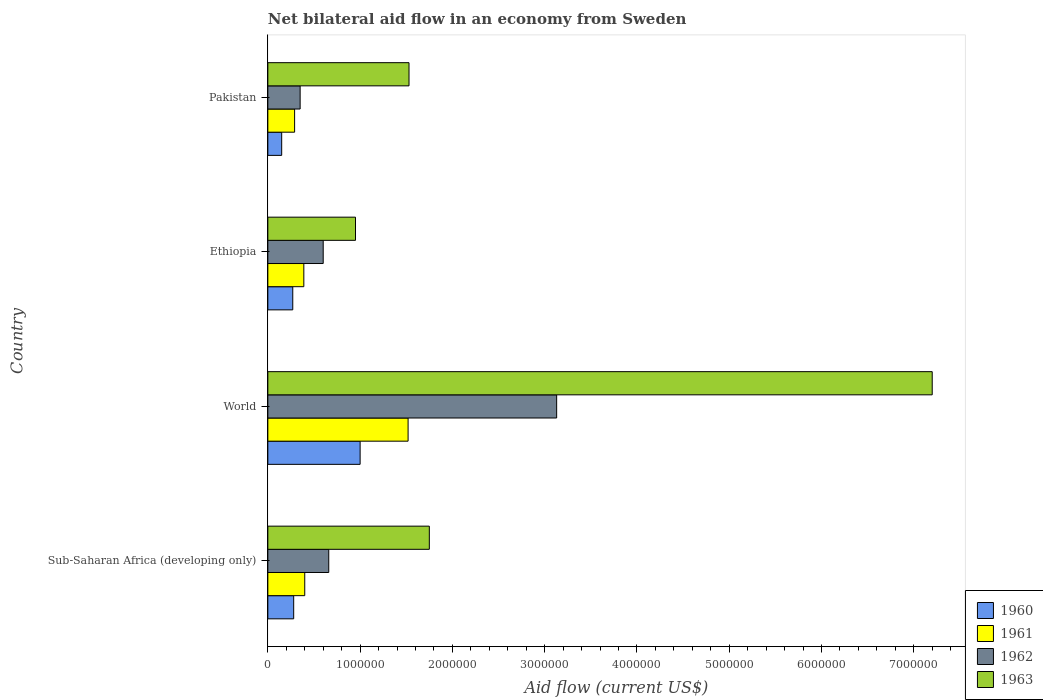How many different coloured bars are there?
Keep it short and to the point. 4. How many groups of bars are there?
Your response must be concise. 4. Are the number of bars per tick equal to the number of legend labels?
Offer a very short reply. Yes. Are the number of bars on each tick of the Y-axis equal?
Provide a succinct answer. Yes. How many bars are there on the 1st tick from the bottom?
Offer a terse response. 4. What is the label of the 4th group of bars from the top?
Give a very brief answer. Sub-Saharan Africa (developing only). In how many cases, is the number of bars for a given country not equal to the number of legend labels?
Your answer should be very brief. 0. What is the net bilateral aid flow in 1962 in Ethiopia?
Your answer should be very brief. 6.00e+05. Across all countries, what is the maximum net bilateral aid flow in 1962?
Your answer should be compact. 3.13e+06. Across all countries, what is the minimum net bilateral aid flow in 1963?
Offer a terse response. 9.50e+05. What is the total net bilateral aid flow in 1961 in the graph?
Provide a short and direct response. 2.60e+06. What is the difference between the net bilateral aid flow in 1963 in Pakistan and that in World?
Your response must be concise. -5.67e+06. What is the difference between the net bilateral aid flow in 1962 in Sub-Saharan Africa (developing only) and the net bilateral aid flow in 1963 in Pakistan?
Provide a short and direct response. -8.70e+05. What is the average net bilateral aid flow in 1960 per country?
Make the answer very short. 4.25e+05. What is the difference between the net bilateral aid flow in 1961 and net bilateral aid flow in 1963 in Ethiopia?
Your response must be concise. -5.60e+05. In how many countries, is the net bilateral aid flow in 1961 greater than 1800000 US$?
Make the answer very short. 0. What is the ratio of the net bilateral aid flow in 1961 in Sub-Saharan Africa (developing only) to that in World?
Ensure brevity in your answer.  0.26. Is the net bilateral aid flow in 1962 in Pakistan less than that in Sub-Saharan Africa (developing only)?
Your response must be concise. Yes. What is the difference between the highest and the second highest net bilateral aid flow in 1962?
Give a very brief answer. 2.47e+06. What is the difference between the highest and the lowest net bilateral aid flow in 1960?
Offer a terse response. 8.50e+05. In how many countries, is the net bilateral aid flow in 1960 greater than the average net bilateral aid flow in 1960 taken over all countries?
Give a very brief answer. 1. What does the 1st bar from the top in Ethiopia represents?
Offer a terse response. 1963. How many bars are there?
Ensure brevity in your answer.  16. Are all the bars in the graph horizontal?
Offer a very short reply. Yes. How many countries are there in the graph?
Give a very brief answer. 4. Are the values on the major ticks of X-axis written in scientific E-notation?
Ensure brevity in your answer.  No. Does the graph contain grids?
Ensure brevity in your answer.  No. Where does the legend appear in the graph?
Your answer should be compact. Bottom right. What is the title of the graph?
Offer a terse response. Net bilateral aid flow in an economy from Sweden. Does "2008" appear as one of the legend labels in the graph?
Keep it short and to the point. No. What is the label or title of the X-axis?
Offer a very short reply. Aid flow (current US$). What is the label or title of the Y-axis?
Your answer should be compact. Country. What is the Aid flow (current US$) in 1960 in Sub-Saharan Africa (developing only)?
Provide a short and direct response. 2.80e+05. What is the Aid flow (current US$) in 1962 in Sub-Saharan Africa (developing only)?
Provide a succinct answer. 6.60e+05. What is the Aid flow (current US$) in 1963 in Sub-Saharan Africa (developing only)?
Offer a very short reply. 1.75e+06. What is the Aid flow (current US$) of 1960 in World?
Give a very brief answer. 1.00e+06. What is the Aid flow (current US$) of 1961 in World?
Provide a succinct answer. 1.52e+06. What is the Aid flow (current US$) of 1962 in World?
Provide a short and direct response. 3.13e+06. What is the Aid flow (current US$) of 1963 in World?
Your answer should be very brief. 7.20e+06. What is the Aid flow (current US$) of 1960 in Ethiopia?
Offer a very short reply. 2.70e+05. What is the Aid flow (current US$) in 1961 in Ethiopia?
Keep it short and to the point. 3.90e+05. What is the Aid flow (current US$) in 1962 in Ethiopia?
Your response must be concise. 6.00e+05. What is the Aid flow (current US$) of 1963 in Ethiopia?
Provide a succinct answer. 9.50e+05. What is the Aid flow (current US$) in 1960 in Pakistan?
Make the answer very short. 1.50e+05. What is the Aid flow (current US$) in 1961 in Pakistan?
Your answer should be compact. 2.90e+05. What is the Aid flow (current US$) of 1963 in Pakistan?
Your answer should be compact. 1.53e+06. Across all countries, what is the maximum Aid flow (current US$) in 1960?
Your response must be concise. 1.00e+06. Across all countries, what is the maximum Aid flow (current US$) of 1961?
Your answer should be compact. 1.52e+06. Across all countries, what is the maximum Aid flow (current US$) in 1962?
Offer a terse response. 3.13e+06. Across all countries, what is the maximum Aid flow (current US$) of 1963?
Your answer should be very brief. 7.20e+06. Across all countries, what is the minimum Aid flow (current US$) of 1961?
Your answer should be compact. 2.90e+05. Across all countries, what is the minimum Aid flow (current US$) of 1963?
Keep it short and to the point. 9.50e+05. What is the total Aid flow (current US$) of 1960 in the graph?
Make the answer very short. 1.70e+06. What is the total Aid flow (current US$) of 1961 in the graph?
Offer a terse response. 2.60e+06. What is the total Aid flow (current US$) of 1962 in the graph?
Provide a short and direct response. 4.74e+06. What is the total Aid flow (current US$) of 1963 in the graph?
Give a very brief answer. 1.14e+07. What is the difference between the Aid flow (current US$) of 1960 in Sub-Saharan Africa (developing only) and that in World?
Your answer should be compact. -7.20e+05. What is the difference between the Aid flow (current US$) in 1961 in Sub-Saharan Africa (developing only) and that in World?
Your response must be concise. -1.12e+06. What is the difference between the Aid flow (current US$) in 1962 in Sub-Saharan Africa (developing only) and that in World?
Provide a succinct answer. -2.47e+06. What is the difference between the Aid flow (current US$) in 1963 in Sub-Saharan Africa (developing only) and that in World?
Ensure brevity in your answer.  -5.45e+06. What is the difference between the Aid flow (current US$) in 1960 in Sub-Saharan Africa (developing only) and that in Ethiopia?
Your answer should be compact. 10000. What is the difference between the Aid flow (current US$) of 1961 in Sub-Saharan Africa (developing only) and that in Ethiopia?
Give a very brief answer. 10000. What is the difference between the Aid flow (current US$) of 1962 in Sub-Saharan Africa (developing only) and that in Ethiopia?
Your response must be concise. 6.00e+04. What is the difference between the Aid flow (current US$) in 1963 in Sub-Saharan Africa (developing only) and that in Ethiopia?
Provide a succinct answer. 8.00e+05. What is the difference between the Aid flow (current US$) of 1962 in Sub-Saharan Africa (developing only) and that in Pakistan?
Give a very brief answer. 3.10e+05. What is the difference between the Aid flow (current US$) of 1960 in World and that in Ethiopia?
Make the answer very short. 7.30e+05. What is the difference between the Aid flow (current US$) in 1961 in World and that in Ethiopia?
Your answer should be compact. 1.13e+06. What is the difference between the Aid flow (current US$) in 1962 in World and that in Ethiopia?
Offer a very short reply. 2.53e+06. What is the difference between the Aid flow (current US$) in 1963 in World and that in Ethiopia?
Keep it short and to the point. 6.25e+06. What is the difference between the Aid flow (current US$) in 1960 in World and that in Pakistan?
Your response must be concise. 8.50e+05. What is the difference between the Aid flow (current US$) in 1961 in World and that in Pakistan?
Make the answer very short. 1.23e+06. What is the difference between the Aid flow (current US$) in 1962 in World and that in Pakistan?
Keep it short and to the point. 2.78e+06. What is the difference between the Aid flow (current US$) in 1963 in World and that in Pakistan?
Your answer should be compact. 5.67e+06. What is the difference between the Aid flow (current US$) in 1960 in Ethiopia and that in Pakistan?
Provide a succinct answer. 1.20e+05. What is the difference between the Aid flow (current US$) of 1961 in Ethiopia and that in Pakistan?
Provide a short and direct response. 1.00e+05. What is the difference between the Aid flow (current US$) of 1963 in Ethiopia and that in Pakistan?
Offer a terse response. -5.80e+05. What is the difference between the Aid flow (current US$) of 1960 in Sub-Saharan Africa (developing only) and the Aid flow (current US$) of 1961 in World?
Provide a short and direct response. -1.24e+06. What is the difference between the Aid flow (current US$) in 1960 in Sub-Saharan Africa (developing only) and the Aid flow (current US$) in 1962 in World?
Provide a succinct answer. -2.85e+06. What is the difference between the Aid flow (current US$) of 1960 in Sub-Saharan Africa (developing only) and the Aid flow (current US$) of 1963 in World?
Offer a very short reply. -6.92e+06. What is the difference between the Aid flow (current US$) of 1961 in Sub-Saharan Africa (developing only) and the Aid flow (current US$) of 1962 in World?
Keep it short and to the point. -2.73e+06. What is the difference between the Aid flow (current US$) of 1961 in Sub-Saharan Africa (developing only) and the Aid flow (current US$) of 1963 in World?
Offer a very short reply. -6.80e+06. What is the difference between the Aid flow (current US$) of 1962 in Sub-Saharan Africa (developing only) and the Aid flow (current US$) of 1963 in World?
Make the answer very short. -6.54e+06. What is the difference between the Aid flow (current US$) in 1960 in Sub-Saharan Africa (developing only) and the Aid flow (current US$) in 1961 in Ethiopia?
Your answer should be very brief. -1.10e+05. What is the difference between the Aid flow (current US$) in 1960 in Sub-Saharan Africa (developing only) and the Aid flow (current US$) in 1962 in Ethiopia?
Provide a succinct answer. -3.20e+05. What is the difference between the Aid flow (current US$) in 1960 in Sub-Saharan Africa (developing only) and the Aid flow (current US$) in 1963 in Ethiopia?
Make the answer very short. -6.70e+05. What is the difference between the Aid flow (current US$) of 1961 in Sub-Saharan Africa (developing only) and the Aid flow (current US$) of 1962 in Ethiopia?
Make the answer very short. -2.00e+05. What is the difference between the Aid flow (current US$) in 1961 in Sub-Saharan Africa (developing only) and the Aid flow (current US$) in 1963 in Ethiopia?
Give a very brief answer. -5.50e+05. What is the difference between the Aid flow (current US$) in 1960 in Sub-Saharan Africa (developing only) and the Aid flow (current US$) in 1963 in Pakistan?
Provide a short and direct response. -1.25e+06. What is the difference between the Aid flow (current US$) of 1961 in Sub-Saharan Africa (developing only) and the Aid flow (current US$) of 1963 in Pakistan?
Your answer should be very brief. -1.13e+06. What is the difference between the Aid flow (current US$) in 1962 in Sub-Saharan Africa (developing only) and the Aid flow (current US$) in 1963 in Pakistan?
Offer a very short reply. -8.70e+05. What is the difference between the Aid flow (current US$) of 1960 in World and the Aid flow (current US$) of 1962 in Ethiopia?
Provide a short and direct response. 4.00e+05. What is the difference between the Aid flow (current US$) in 1960 in World and the Aid flow (current US$) in 1963 in Ethiopia?
Make the answer very short. 5.00e+04. What is the difference between the Aid flow (current US$) in 1961 in World and the Aid flow (current US$) in 1962 in Ethiopia?
Offer a very short reply. 9.20e+05. What is the difference between the Aid flow (current US$) of 1961 in World and the Aid flow (current US$) of 1963 in Ethiopia?
Offer a very short reply. 5.70e+05. What is the difference between the Aid flow (current US$) in 1962 in World and the Aid flow (current US$) in 1963 in Ethiopia?
Offer a terse response. 2.18e+06. What is the difference between the Aid flow (current US$) of 1960 in World and the Aid flow (current US$) of 1961 in Pakistan?
Offer a very short reply. 7.10e+05. What is the difference between the Aid flow (current US$) in 1960 in World and the Aid flow (current US$) in 1962 in Pakistan?
Give a very brief answer. 6.50e+05. What is the difference between the Aid flow (current US$) of 1960 in World and the Aid flow (current US$) of 1963 in Pakistan?
Offer a terse response. -5.30e+05. What is the difference between the Aid flow (current US$) in 1961 in World and the Aid flow (current US$) in 1962 in Pakistan?
Keep it short and to the point. 1.17e+06. What is the difference between the Aid flow (current US$) in 1962 in World and the Aid flow (current US$) in 1963 in Pakistan?
Make the answer very short. 1.60e+06. What is the difference between the Aid flow (current US$) in 1960 in Ethiopia and the Aid flow (current US$) in 1961 in Pakistan?
Provide a short and direct response. -2.00e+04. What is the difference between the Aid flow (current US$) in 1960 in Ethiopia and the Aid flow (current US$) in 1963 in Pakistan?
Provide a short and direct response. -1.26e+06. What is the difference between the Aid flow (current US$) in 1961 in Ethiopia and the Aid flow (current US$) in 1962 in Pakistan?
Give a very brief answer. 4.00e+04. What is the difference between the Aid flow (current US$) in 1961 in Ethiopia and the Aid flow (current US$) in 1963 in Pakistan?
Make the answer very short. -1.14e+06. What is the difference between the Aid flow (current US$) in 1962 in Ethiopia and the Aid flow (current US$) in 1963 in Pakistan?
Offer a very short reply. -9.30e+05. What is the average Aid flow (current US$) in 1960 per country?
Your answer should be compact. 4.25e+05. What is the average Aid flow (current US$) of 1961 per country?
Give a very brief answer. 6.50e+05. What is the average Aid flow (current US$) in 1962 per country?
Your answer should be very brief. 1.18e+06. What is the average Aid flow (current US$) in 1963 per country?
Provide a short and direct response. 2.86e+06. What is the difference between the Aid flow (current US$) in 1960 and Aid flow (current US$) in 1961 in Sub-Saharan Africa (developing only)?
Offer a very short reply. -1.20e+05. What is the difference between the Aid flow (current US$) of 1960 and Aid flow (current US$) of 1962 in Sub-Saharan Africa (developing only)?
Provide a short and direct response. -3.80e+05. What is the difference between the Aid flow (current US$) of 1960 and Aid flow (current US$) of 1963 in Sub-Saharan Africa (developing only)?
Your answer should be very brief. -1.47e+06. What is the difference between the Aid flow (current US$) in 1961 and Aid flow (current US$) in 1963 in Sub-Saharan Africa (developing only)?
Keep it short and to the point. -1.35e+06. What is the difference between the Aid flow (current US$) of 1962 and Aid flow (current US$) of 1963 in Sub-Saharan Africa (developing only)?
Offer a very short reply. -1.09e+06. What is the difference between the Aid flow (current US$) in 1960 and Aid flow (current US$) in 1961 in World?
Ensure brevity in your answer.  -5.20e+05. What is the difference between the Aid flow (current US$) in 1960 and Aid flow (current US$) in 1962 in World?
Make the answer very short. -2.13e+06. What is the difference between the Aid flow (current US$) in 1960 and Aid flow (current US$) in 1963 in World?
Your answer should be compact. -6.20e+06. What is the difference between the Aid flow (current US$) of 1961 and Aid flow (current US$) of 1962 in World?
Your answer should be very brief. -1.61e+06. What is the difference between the Aid flow (current US$) of 1961 and Aid flow (current US$) of 1963 in World?
Keep it short and to the point. -5.68e+06. What is the difference between the Aid flow (current US$) of 1962 and Aid flow (current US$) of 1963 in World?
Ensure brevity in your answer.  -4.07e+06. What is the difference between the Aid flow (current US$) in 1960 and Aid flow (current US$) in 1962 in Ethiopia?
Keep it short and to the point. -3.30e+05. What is the difference between the Aid flow (current US$) of 1960 and Aid flow (current US$) of 1963 in Ethiopia?
Keep it short and to the point. -6.80e+05. What is the difference between the Aid flow (current US$) in 1961 and Aid flow (current US$) in 1962 in Ethiopia?
Keep it short and to the point. -2.10e+05. What is the difference between the Aid flow (current US$) of 1961 and Aid flow (current US$) of 1963 in Ethiopia?
Your response must be concise. -5.60e+05. What is the difference between the Aid flow (current US$) of 1962 and Aid flow (current US$) of 1963 in Ethiopia?
Ensure brevity in your answer.  -3.50e+05. What is the difference between the Aid flow (current US$) of 1960 and Aid flow (current US$) of 1961 in Pakistan?
Give a very brief answer. -1.40e+05. What is the difference between the Aid flow (current US$) of 1960 and Aid flow (current US$) of 1962 in Pakistan?
Offer a very short reply. -2.00e+05. What is the difference between the Aid flow (current US$) in 1960 and Aid flow (current US$) in 1963 in Pakistan?
Ensure brevity in your answer.  -1.38e+06. What is the difference between the Aid flow (current US$) of 1961 and Aid flow (current US$) of 1962 in Pakistan?
Give a very brief answer. -6.00e+04. What is the difference between the Aid flow (current US$) of 1961 and Aid flow (current US$) of 1963 in Pakistan?
Your answer should be very brief. -1.24e+06. What is the difference between the Aid flow (current US$) of 1962 and Aid flow (current US$) of 1963 in Pakistan?
Make the answer very short. -1.18e+06. What is the ratio of the Aid flow (current US$) in 1960 in Sub-Saharan Africa (developing only) to that in World?
Provide a succinct answer. 0.28. What is the ratio of the Aid flow (current US$) of 1961 in Sub-Saharan Africa (developing only) to that in World?
Make the answer very short. 0.26. What is the ratio of the Aid flow (current US$) in 1962 in Sub-Saharan Africa (developing only) to that in World?
Provide a succinct answer. 0.21. What is the ratio of the Aid flow (current US$) in 1963 in Sub-Saharan Africa (developing only) to that in World?
Keep it short and to the point. 0.24. What is the ratio of the Aid flow (current US$) of 1960 in Sub-Saharan Africa (developing only) to that in Ethiopia?
Offer a terse response. 1.04. What is the ratio of the Aid flow (current US$) in 1961 in Sub-Saharan Africa (developing only) to that in Ethiopia?
Offer a very short reply. 1.03. What is the ratio of the Aid flow (current US$) in 1962 in Sub-Saharan Africa (developing only) to that in Ethiopia?
Ensure brevity in your answer.  1.1. What is the ratio of the Aid flow (current US$) in 1963 in Sub-Saharan Africa (developing only) to that in Ethiopia?
Offer a very short reply. 1.84. What is the ratio of the Aid flow (current US$) of 1960 in Sub-Saharan Africa (developing only) to that in Pakistan?
Offer a very short reply. 1.87. What is the ratio of the Aid flow (current US$) in 1961 in Sub-Saharan Africa (developing only) to that in Pakistan?
Give a very brief answer. 1.38. What is the ratio of the Aid flow (current US$) in 1962 in Sub-Saharan Africa (developing only) to that in Pakistan?
Your answer should be compact. 1.89. What is the ratio of the Aid flow (current US$) in 1963 in Sub-Saharan Africa (developing only) to that in Pakistan?
Offer a terse response. 1.14. What is the ratio of the Aid flow (current US$) in 1960 in World to that in Ethiopia?
Provide a short and direct response. 3.7. What is the ratio of the Aid flow (current US$) of 1961 in World to that in Ethiopia?
Your answer should be compact. 3.9. What is the ratio of the Aid flow (current US$) of 1962 in World to that in Ethiopia?
Your answer should be very brief. 5.22. What is the ratio of the Aid flow (current US$) of 1963 in World to that in Ethiopia?
Provide a succinct answer. 7.58. What is the ratio of the Aid flow (current US$) of 1961 in World to that in Pakistan?
Ensure brevity in your answer.  5.24. What is the ratio of the Aid flow (current US$) in 1962 in World to that in Pakistan?
Provide a succinct answer. 8.94. What is the ratio of the Aid flow (current US$) of 1963 in World to that in Pakistan?
Keep it short and to the point. 4.71. What is the ratio of the Aid flow (current US$) in 1961 in Ethiopia to that in Pakistan?
Give a very brief answer. 1.34. What is the ratio of the Aid flow (current US$) in 1962 in Ethiopia to that in Pakistan?
Provide a short and direct response. 1.71. What is the ratio of the Aid flow (current US$) of 1963 in Ethiopia to that in Pakistan?
Ensure brevity in your answer.  0.62. What is the difference between the highest and the second highest Aid flow (current US$) in 1960?
Ensure brevity in your answer.  7.20e+05. What is the difference between the highest and the second highest Aid flow (current US$) of 1961?
Offer a very short reply. 1.12e+06. What is the difference between the highest and the second highest Aid flow (current US$) in 1962?
Keep it short and to the point. 2.47e+06. What is the difference between the highest and the second highest Aid flow (current US$) of 1963?
Your answer should be very brief. 5.45e+06. What is the difference between the highest and the lowest Aid flow (current US$) in 1960?
Give a very brief answer. 8.50e+05. What is the difference between the highest and the lowest Aid flow (current US$) in 1961?
Offer a terse response. 1.23e+06. What is the difference between the highest and the lowest Aid flow (current US$) of 1962?
Make the answer very short. 2.78e+06. What is the difference between the highest and the lowest Aid flow (current US$) of 1963?
Your response must be concise. 6.25e+06. 